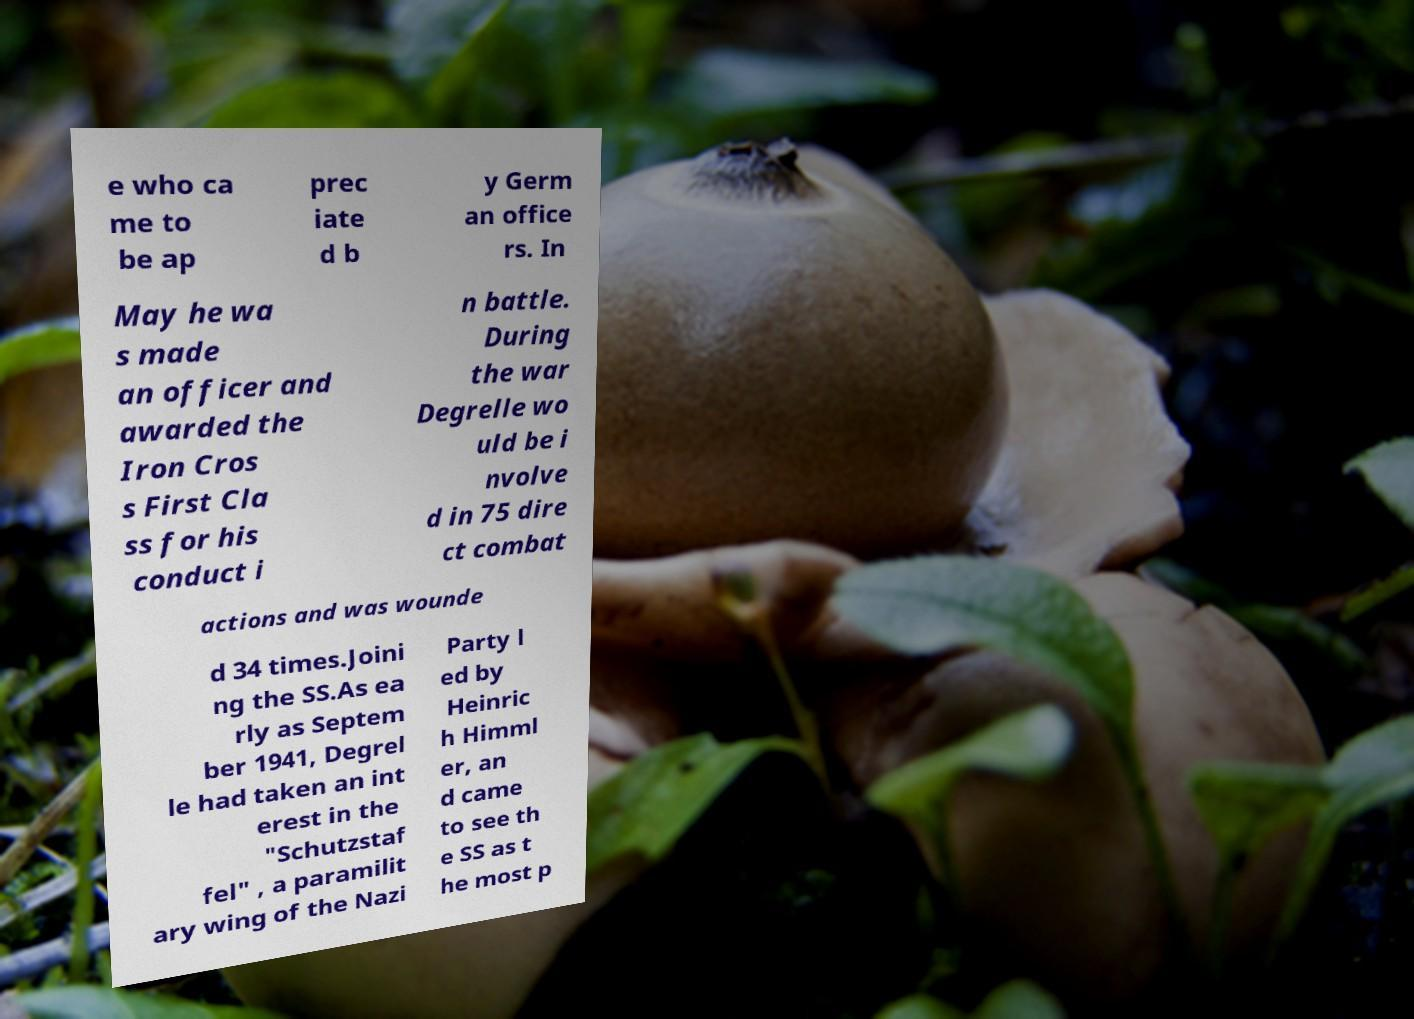There's text embedded in this image that I need extracted. Can you transcribe it verbatim? e who ca me to be ap prec iate d b y Germ an office rs. In May he wa s made an officer and awarded the Iron Cros s First Cla ss for his conduct i n battle. During the war Degrelle wo uld be i nvolve d in 75 dire ct combat actions and was wounde d 34 times.Joini ng the SS.As ea rly as Septem ber 1941, Degrel le had taken an int erest in the "Schutzstaf fel" , a paramilit ary wing of the Nazi Party l ed by Heinric h Himml er, an d came to see th e SS as t he most p 